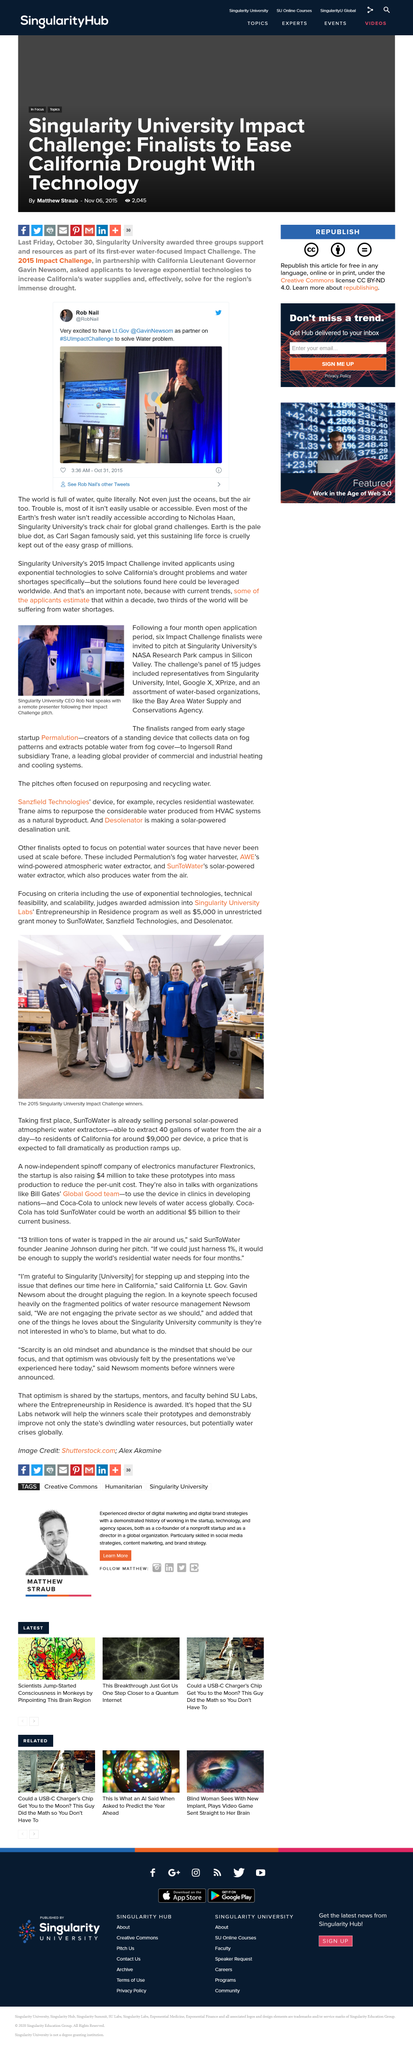Mention a couple of crucial points in this snapshot. On October 31, 2015, at 3:36 am, Rob Nail wrote his tweet. On January 20, 2015, Rob Nail tweeted about the Impact Challenge. Trane aims to repurpose the substantial amount of water produced from HVAC systems as a natural byproduct, towards sustainable and efficient use. The winners were awarded a total of $5000 in unrestricted grant money. The Impact Challenge aimed to address the pressing issue of California's severe drought and water shortages through innovative and sustainable solutions that would promote efficient use of water resources. 